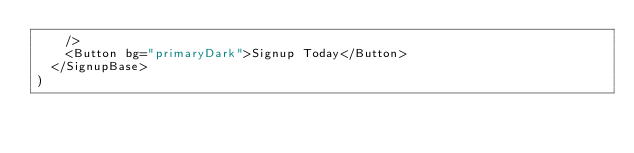Convert code to text. <code><loc_0><loc_0><loc_500><loc_500><_JavaScript_>    />
    <Button bg="primaryDark">Signup Today</Button>
  </SignupBase>
)
</code> 